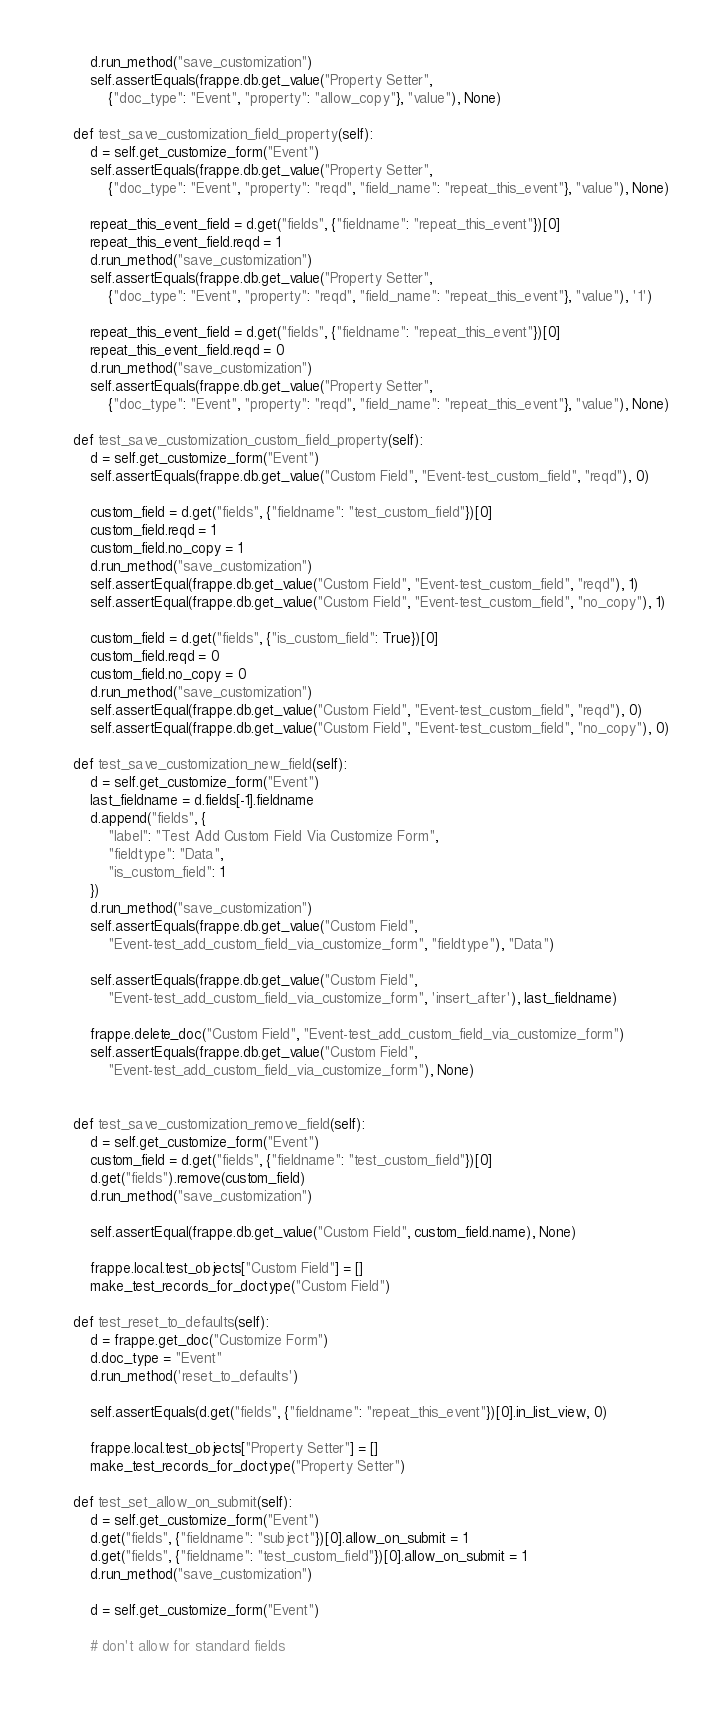Convert code to text. <code><loc_0><loc_0><loc_500><loc_500><_Python_>		d.run_method("save_customization")
		self.assertEquals(frappe.db.get_value("Property Setter",
			{"doc_type": "Event", "property": "allow_copy"}, "value"), None)

	def test_save_customization_field_property(self):
		d = self.get_customize_form("Event")
		self.assertEquals(frappe.db.get_value("Property Setter",
			{"doc_type": "Event", "property": "reqd", "field_name": "repeat_this_event"}, "value"), None)

		repeat_this_event_field = d.get("fields", {"fieldname": "repeat_this_event"})[0]
		repeat_this_event_field.reqd = 1
		d.run_method("save_customization")
		self.assertEquals(frappe.db.get_value("Property Setter",
			{"doc_type": "Event", "property": "reqd", "field_name": "repeat_this_event"}, "value"), '1')

		repeat_this_event_field = d.get("fields", {"fieldname": "repeat_this_event"})[0]
		repeat_this_event_field.reqd = 0
		d.run_method("save_customization")
		self.assertEquals(frappe.db.get_value("Property Setter",
			{"doc_type": "Event", "property": "reqd", "field_name": "repeat_this_event"}, "value"), None)

	def test_save_customization_custom_field_property(self):
		d = self.get_customize_form("Event")
		self.assertEquals(frappe.db.get_value("Custom Field", "Event-test_custom_field", "reqd"), 0)

		custom_field = d.get("fields", {"fieldname": "test_custom_field"})[0]
		custom_field.reqd = 1
		custom_field.no_copy = 1
		d.run_method("save_customization")
		self.assertEqual(frappe.db.get_value("Custom Field", "Event-test_custom_field", "reqd"), 1)
		self.assertEqual(frappe.db.get_value("Custom Field", "Event-test_custom_field", "no_copy"), 1)

		custom_field = d.get("fields", {"is_custom_field": True})[0]
		custom_field.reqd = 0
		custom_field.no_copy = 0
		d.run_method("save_customization")
		self.assertEqual(frappe.db.get_value("Custom Field", "Event-test_custom_field", "reqd"), 0)
		self.assertEqual(frappe.db.get_value("Custom Field", "Event-test_custom_field", "no_copy"), 0)

	def test_save_customization_new_field(self):
		d = self.get_customize_form("Event")
		last_fieldname = d.fields[-1].fieldname
		d.append("fields", {
			"label": "Test Add Custom Field Via Customize Form",
			"fieldtype": "Data",
			"is_custom_field": 1
		})
		d.run_method("save_customization")
		self.assertEquals(frappe.db.get_value("Custom Field",
			"Event-test_add_custom_field_via_customize_form", "fieldtype"), "Data")

		self.assertEquals(frappe.db.get_value("Custom Field",
			"Event-test_add_custom_field_via_customize_form", 'insert_after'), last_fieldname)

		frappe.delete_doc("Custom Field", "Event-test_add_custom_field_via_customize_form")
		self.assertEquals(frappe.db.get_value("Custom Field",
			"Event-test_add_custom_field_via_customize_form"), None)


	def test_save_customization_remove_field(self):
		d = self.get_customize_form("Event")
		custom_field = d.get("fields", {"fieldname": "test_custom_field"})[0]
		d.get("fields").remove(custom_field)
		d.run_method("save_customization")

		self.assertEqual(frappe.db.get_value("Custom Field", custom_field.name), None)

		frappe.local.test_objects["Custom Field"] = []
		make_test_records_for_doctype("Custom Field")

	def test_reset_to_defaults(self):
		d = frappe.get_doc("Customize Form")
		d.doc_type = "Event"
		d.run_method('reset_to_defaults')

		self.assertEquals(d.get("fields", {"fieldname": "repeat_this_event"})[0].in_list_view, 0)

		frappe.local.test_objects["Property Setter"] = []
		make_test_records_for_doctype("Property Setter")

	def test_set_allow_on_submit(self):
		d = self.get_customize_form("Event")
		d.get("fields", {"fieldname": "subject"})[0].allow_on_submit = 1
		d.get("fields", {"fieldname": "test_custom_field"})[0].allow_on_submit = 1
		d.run_method("save_customization")

		d = self.get_customize_form("Event")

		# don't allow for standard fields</code> 